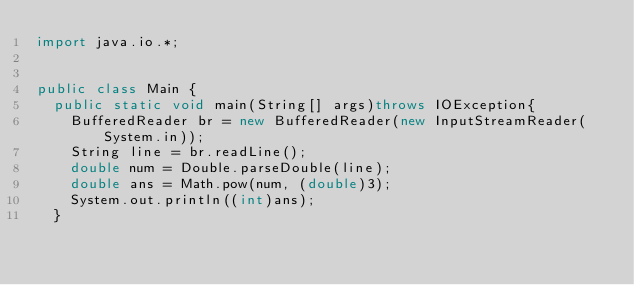<code> <loc_0><loc_0><loc_500><loc_500><_Java_>import java.io.*;


public class Main {  
	public static void main(String[] args)throws IOException{
		BufferedReader br = new BufferedReader(new InputStreamReader(System.in));
		String line = br.readLine();
		double num = Double.parseDouble(line);
		double ans = Math.pow(num, (double)3);
		System.out.println((int)ans);
	}</code> 